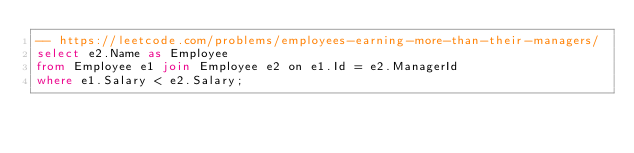Convert code to text. <code><loc_0><loc_0><loc_500><loc_500><_SQL_>-- https://leetcode.com/problems/employees-earning-more-than-their-managers/
select e2.Name as Employee
from Employee e1 join Employee e2 on e1.Id = e2.ManagerId
where e1.Salary < e2.Salary;</code> 